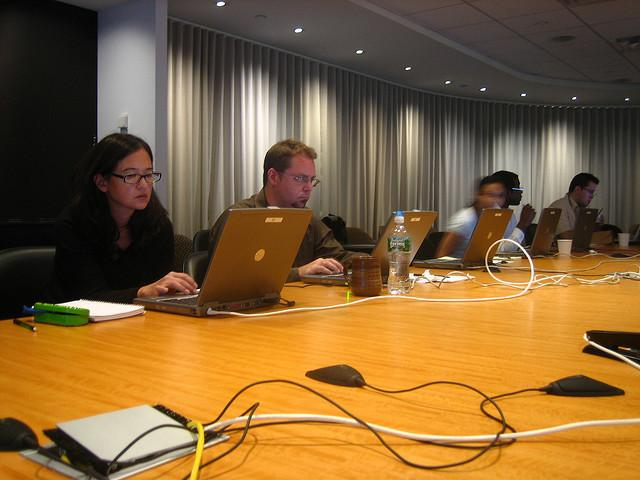What are the people doing in this venue? working 